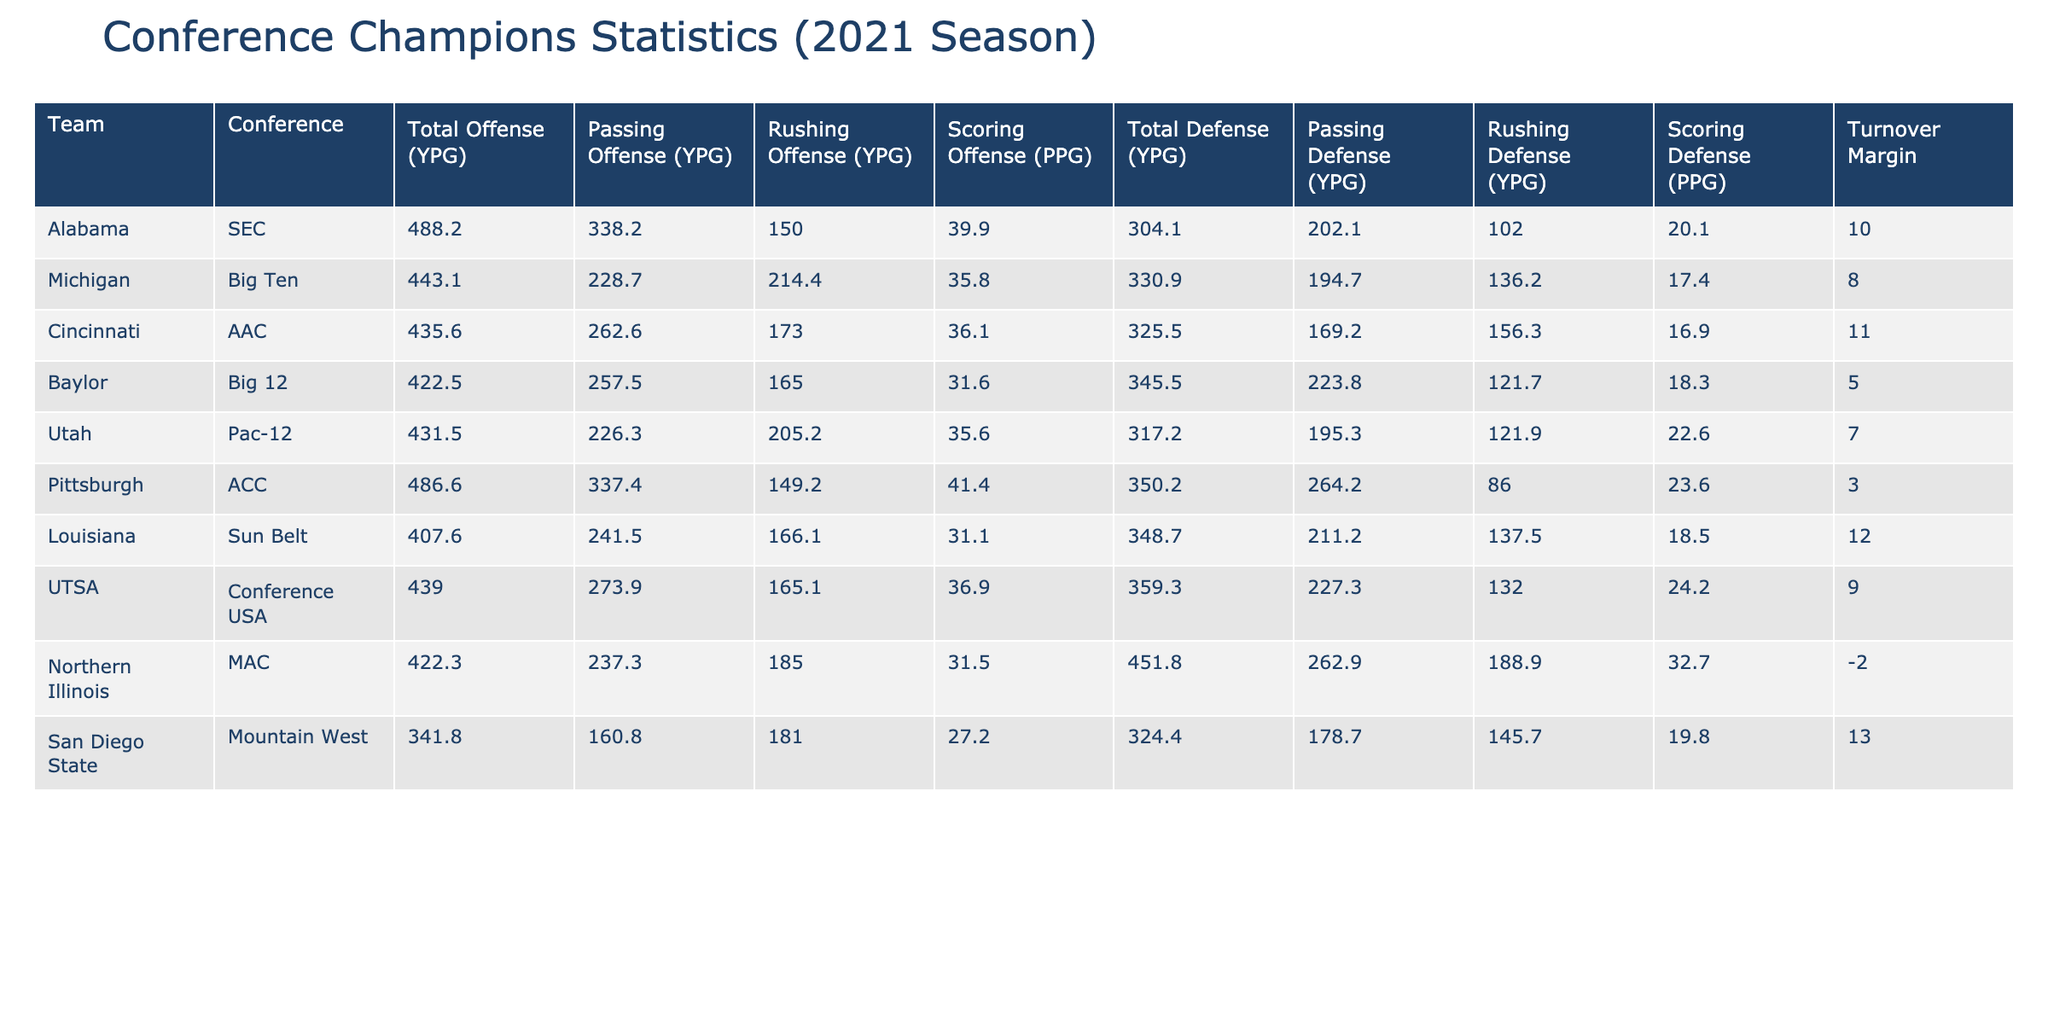What is the total offense per game for Alabama? The table shows the "Total Offense (YPG)" column. For Alabama, this value is listed directly in the table as 488.2.
Answer: 488.2 Which team had the highest scoring defense in the 2021 season? By reviewing the "Scoring Defense (PPG)" column, we can see that Northern Illinois had the highest value at 32.7 PPG.
Answer: Northern Illinois What is the average rushing offense per game of the teams listed? To find the average rushing offense, we add the rushing offense values for all teams: (150.0 + 214.4 + 173.0 + 165.0 + 205.2 + 149.2 + 166.1 + 165.1 + 185.0 + 181.0) = 1,619. The total number of teams is 10, so average = 1,619 / 10 = 161.9.
Answer: 161.9 Did any team have a negative turnover margin? The "Turnover Margin" column indicates that Northern Illinois has a turnover margin of -2, which is negative.
Answer: Yes Which team had the best turnover margin and what was it? The "Turnover Margin" column shows that Alabama had the best turnover margin at +10.
Answer: Alabama, +10 How does the total defense of Pittsburgh compare to that of Cincinnati? From the "Total Defense (YPG)" column, Pittsburgh has 350.2 YPG and Cincinnati has 325.5 YPG. Pittsburgh's defense is worse by a difference of 350.2 - 325.5 = 24.7 yards.
Answer: Pittsburgh is worse by 24.7 YPG What is the difference in rushing defense between Louisiana and Utah? Looking at the "Rushing Defense (YPG)" values, Louisiana has 137.5 YPG and Utah has 121.9 YPG. The difference is calculated as 137.5 - 121.9 = 15.6 YPG.
Answer: 15.6 YPG Which conference had the team with the highest scoring offense? The "Scoring Offense (PPG)" column shows Pittsburgh with the highest scoring offense at 41.4 PPG. Pittsburgh is in the ACC.
Answer: ACC Did any teams score more than 40 points per game? The "Scoring Offense (PPG)" column should be reviewed, and we see that both Alabama (39.9) and Pittsburgh (41.4) exceed 40 PPG. Only Pittsburgh qualifies.
Answer: Yes, Pittsburgh Compare the total offense of Michigan and Baylor. Which team had better stats? By checking the "Total Offense (YPG)" values, Michigan has 443.1 YPG and Baylor has 422.5 YPG, showing that Michigan had a better total offense by 20.6 YPG.
Answer: Michigan, better by 20.6 YPG What was the average scoring offense of all the conference champions? Adding the scoring offense values: (39.9 + 35.8 + 36.1 + 31.6 + 35.6 + 41.4 + 31.1 + 36.9 + 31.5 + 27.2) =  397.2. There are 10 teams, so the average scoring offense = 397.2 / 10 = 39.72.
Answer: 39.72 PPG 